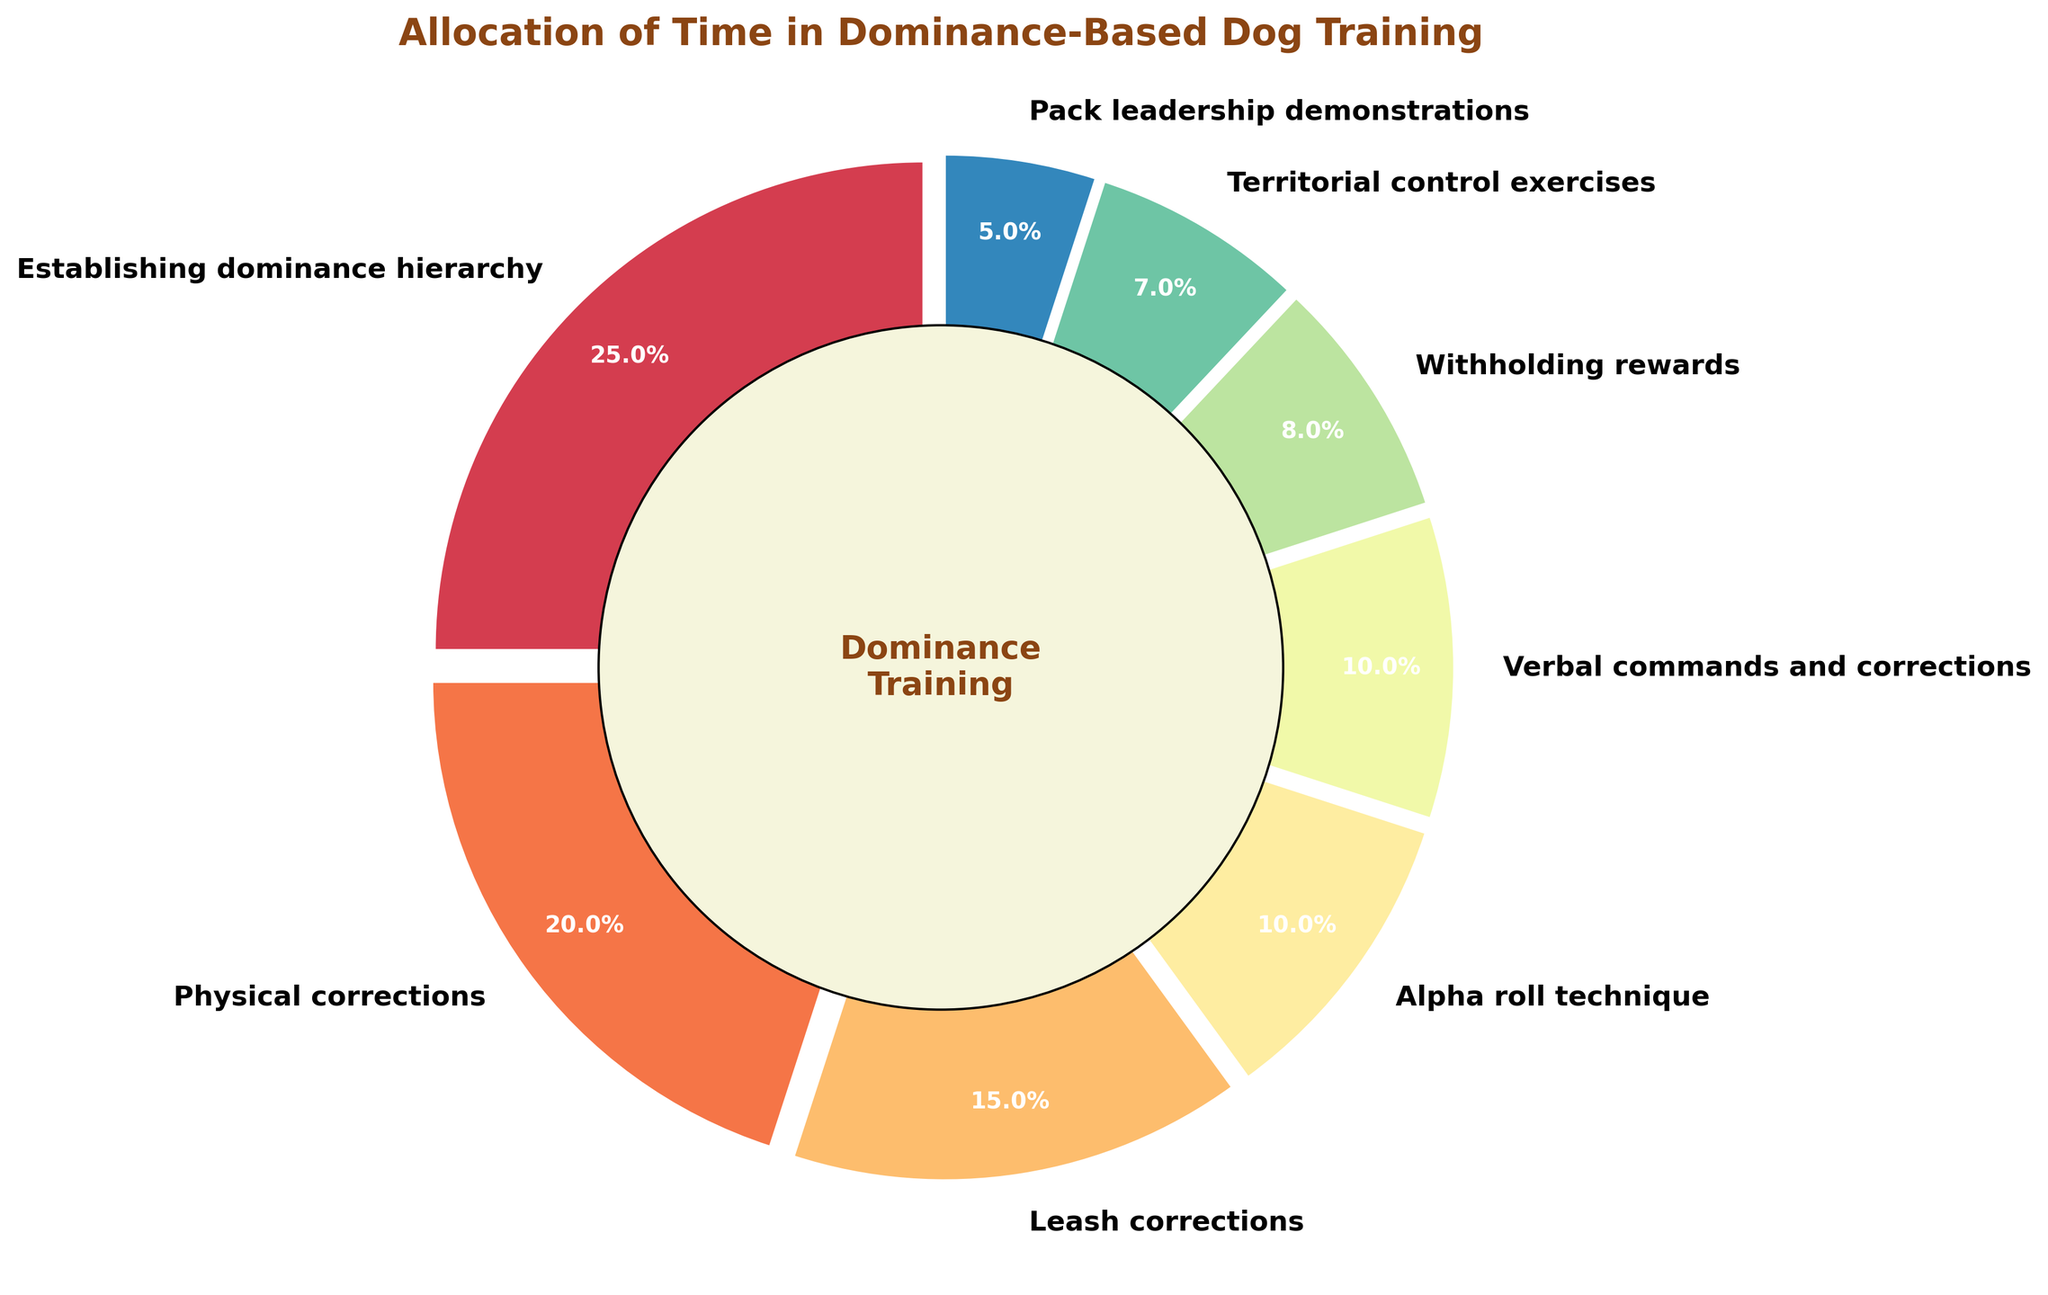What aspect has the highest percentage of time allocation? From the pie chart, the segment labeled "Establishing dominance hierarchy" has the largest size, indicating it has the highest percentage of time allocation.
Answer: Establishing dominance hierarchy How much more time is spent on establishing dominance hierarchy compared to alpha roll technique? The percentage for establishing dominance hierarchy is 25%, whereas for the alpha roll technique it is 10%. Subtracting these gives 25% - 10% = 15%.
Answer: 15% What is the combined percentage of time spent on physical corrections and leash corrections? The percentage for physical corrections is 20% and for leash corrections, it is 15%. Summing these gives 20% + 15% = 35%.
Answer: 35% Which aspect has the smallest percentage of time allocation? The smallest segment in the pie chart is labeled "Pack leadership demonstrations," indicating it has the smallest percentage of time allocation.
Answer: Pack leadership demonstrations Are more time and fewer time spent on withholding rewards than territorial control exercises? From the pie chart, the percentage for withholding rewards is 8% and for territorial control exercises, it is 7%. Since 8% is greater than 7%, more time is spent on withholding rewards.
Answer: Yes What is the difference in the percentage of time allocation between verbal commands and corrections and pack leadership demonstrations? The percentage for verbal commands and corrections is 10%, whereas for pack leadership demonstrations, it is 5%. Subtracting these gives 10% - 5% = 5%.
Answer: 5% Is the percentage of time spent on physical corrections greater than that on verbal commands and corrections? The percentage for physical corrections is 20%, and for verbal commands and corrections, it is 10%. Since 20% is greater than 10%, yes, more time is spent on physical corrections.
Answer: Yes Which two aspects combined make up 25% of the time allocation? The percentages for withholding rewards and territorial control exercises are 8% and 7%, respectively. Summing them gives 8% + 7% = 15%. However, the percentages for territorial control exercises and pack leadership demonstration are 7% and 5%, respectively, giving 7% + 5% = 12%. Therefore, withholding rewards (8%) and alpha roll technique (10%) adds up to 8% + 10% = 18%, which isn't 25%. So, the combined percentage for leash corrections (15%) and pack leadership demonstrations (5%) adds up to 15% + 5% = 20%. But combined percentage for withholding rewards (8%) and leash corrections (15%) gives 8% + 15% = 23%, and finally combining alpha roll technique (10%) and verbal commands and corrections (10%) gives 10% + 10% = 20%, leaving none adding up exactly to 25%.
Answer: None 